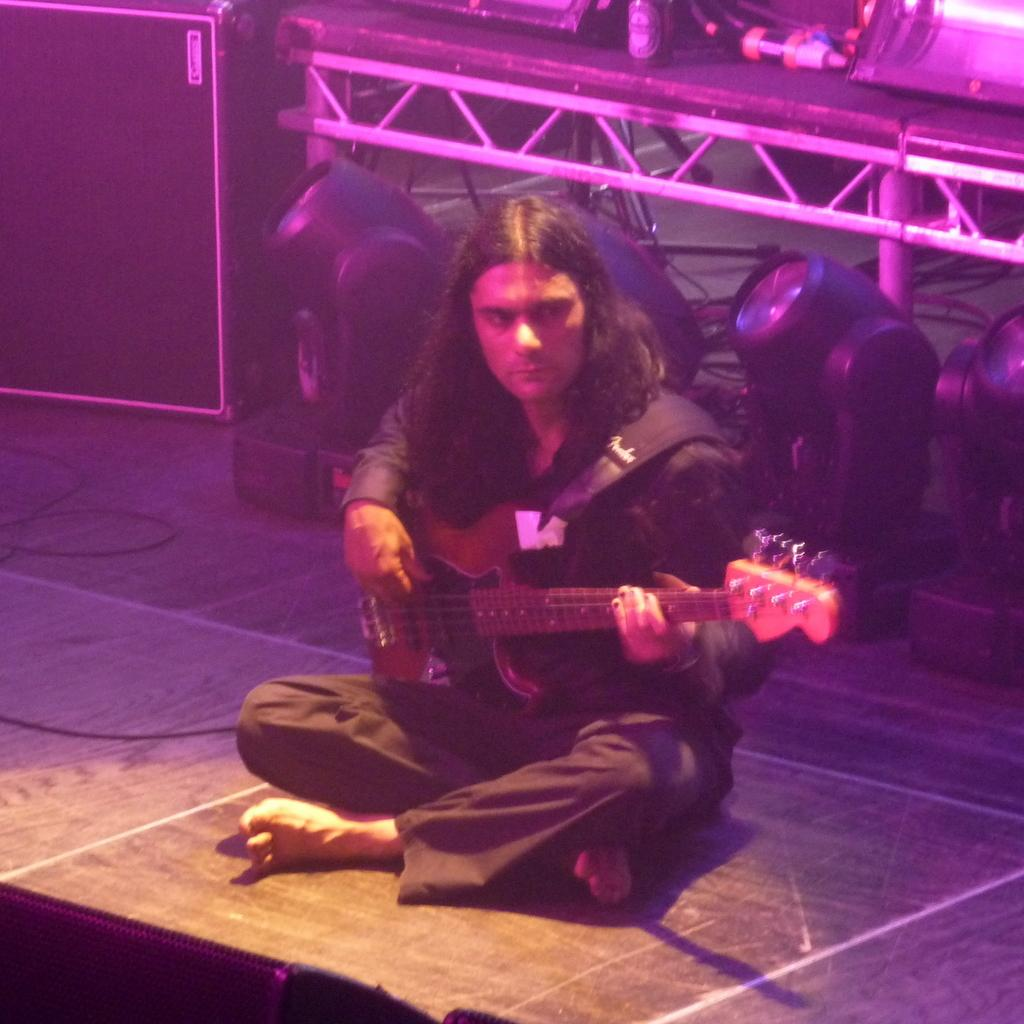What is the appearance of the man in the image? The man in the image has long hair. Where is the man located in the image? The man is sitting on the stage. What is the man holding in the image? The man is holding a guitar. What can be seen in the background of the image? There are poles, lights, and a box in the background of the image. What type of thunder can be heard during the man's performance in the image? There is no sound present in the image, so it is not possible to determine if any thunder can be heard. 